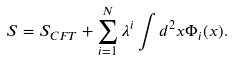<formula> <loc_0><loc_0><loc_500><loc_500>S = S _ { C F T } + \sum _ { i = 1 } ^ { N } \lambda ^ { i } \int d ^ { 2 } x \Phi _ { i } ( x ) .</formula> 